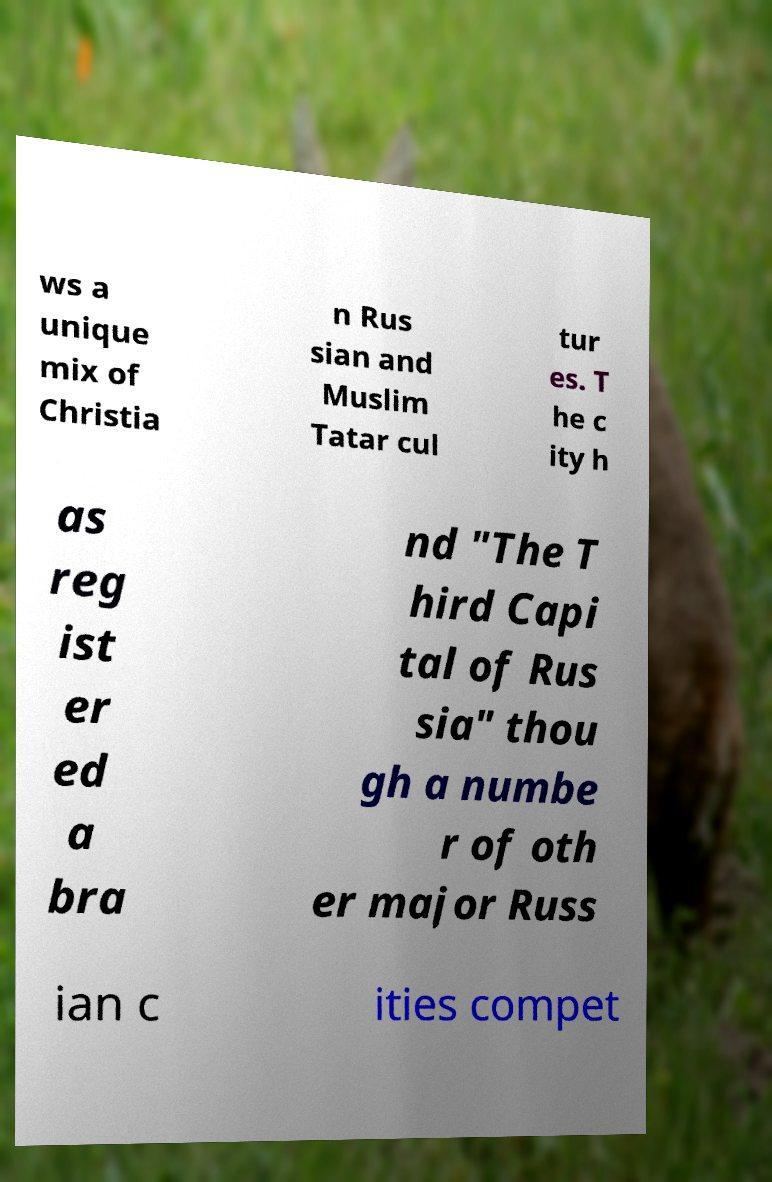Can you read and provide the text displayed in the image?This photo seems to have some interesting text. Can you extract and type it out for me? ws a unique mix of Christia n Rus sian and Muslim Tatar cul tur es. T he c ity h as reg ist er ed a bra nd "The T hird Capi tal of Rus sia" thou gh a numbe r of oth er major Russ ian c ities compet 